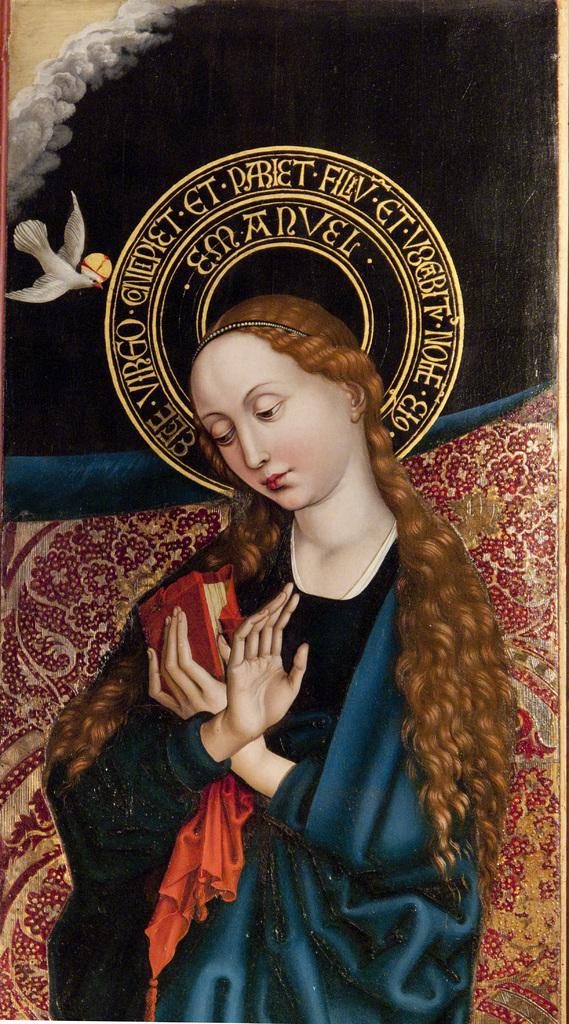What is the main subject of the painting? The painting depicts a lady. What object can be seen with the lady in the painting? There is a book in the painting. Are there any animals present in the painting? Yes, there is a bird in the painting. What type of meal is being prepared by the lady in the painting? There is no indication of a meal being prepared in the painting; the lady is depicted with a book and a bird. 